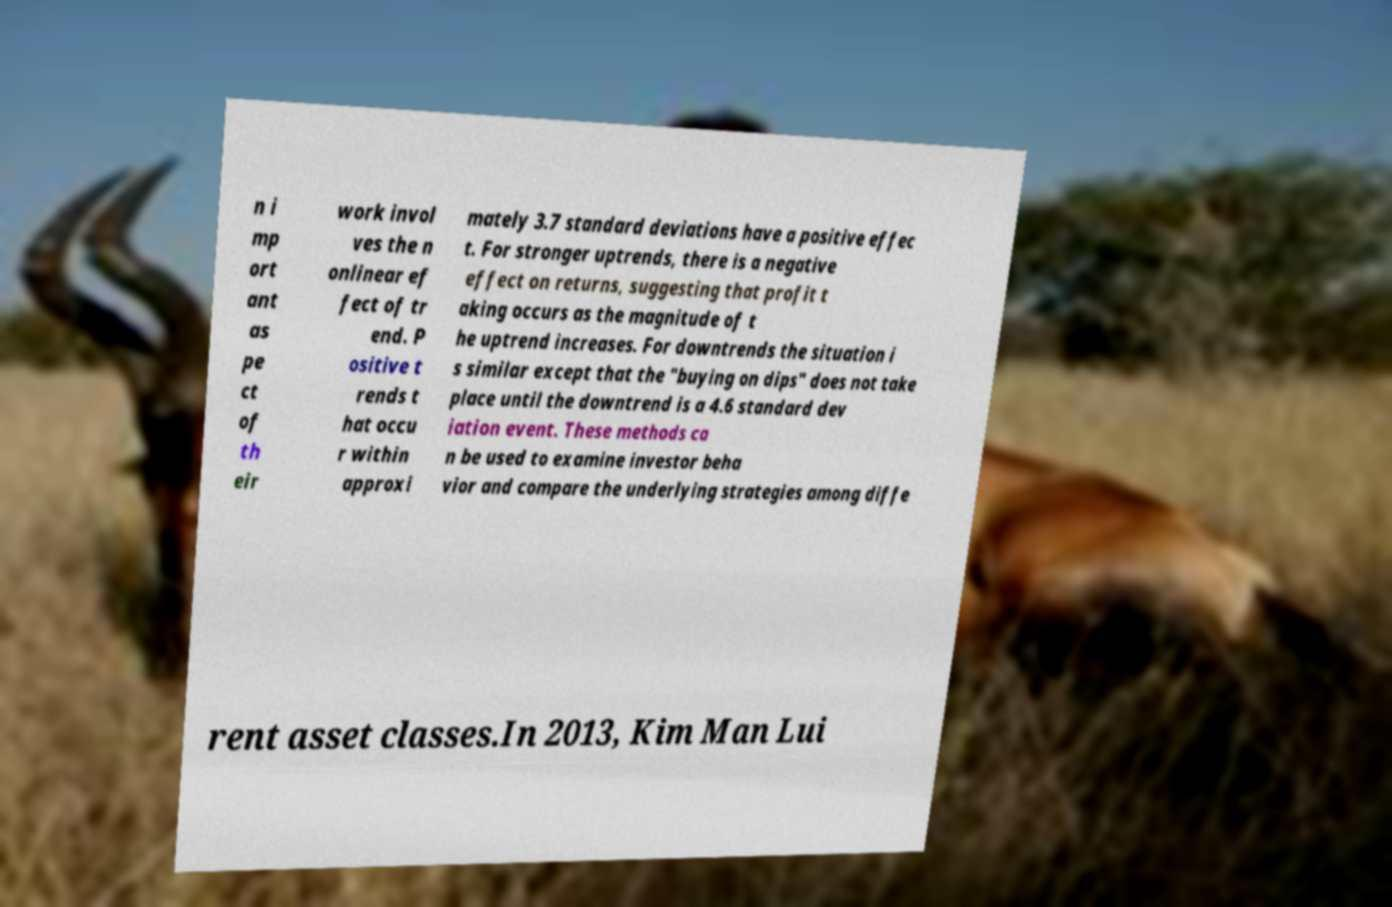I need the written content from this picture converted into text. Can you do that? n i mp ort ant as pe ct of th eir work invol ves the n onlinear ef fect of tr end. P ositive t rends t hat occu r within approxi mately 3.7 standard deviations have a positive effec t. For stronger uptrends, there is a negative effect on returns, suggesting that profit t aking occurs as the magnitude of t he uptrend increases. For downtrends the situation i s similar except that the "buying on dips" does not take place until the downtrend is a 4.6 standard dev iation event. These methods ca n be used to examine investor beha vior and compare the underlying strategies among diffe rent asset classes.In 2013, Kim Man Lui 